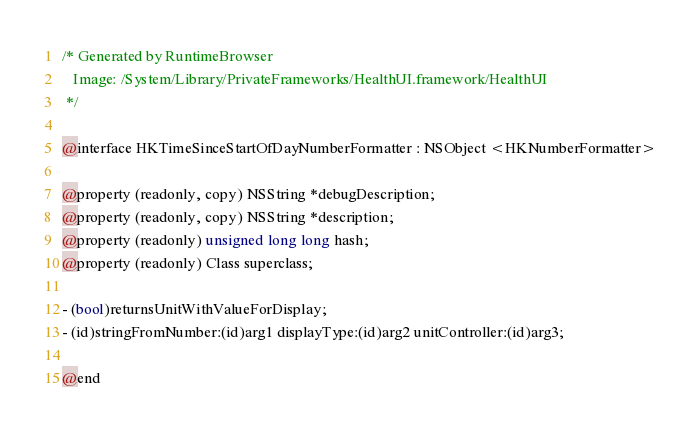Convert code to text. <code><loc_0><loc_0><loc_500><loc_500><_C_>/* Generated by RuntimeBrowser
   Image: /System/Library/PrivateFrameworks/HealthUI.framework/HealthUI
 */

@interface HKTimeSinceStartOfDayNumberFormatter : NSObject <HKNumberFormatter>

@property (readonly, copy) NSString *debugDescription;
@property (readonly, copy) NSString *description;
@property (readonly) unsigned long long hash;
@property (readonly) Class superclass;

- (bool)returnsUnitWithValueForDisplay;
- (id)stringFromNumber:(id)arg1 displayType:(id)arg2 unitController:(id)arg3;

@end
</code> 